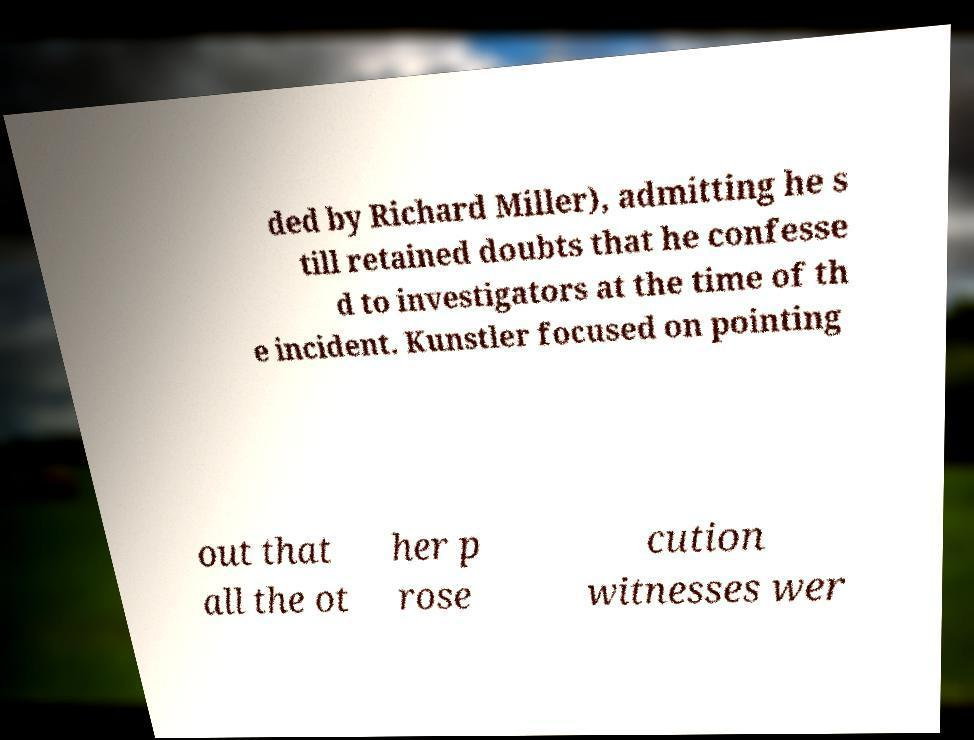Please read and relay the text visible in this image. What does it say? ded by Richard Miller), admitting he s till retained doubts that he confesse d to investigators at the time of th e incident. Kunstler focused on pointing out that all the ot her p rose cution witnesses wer 